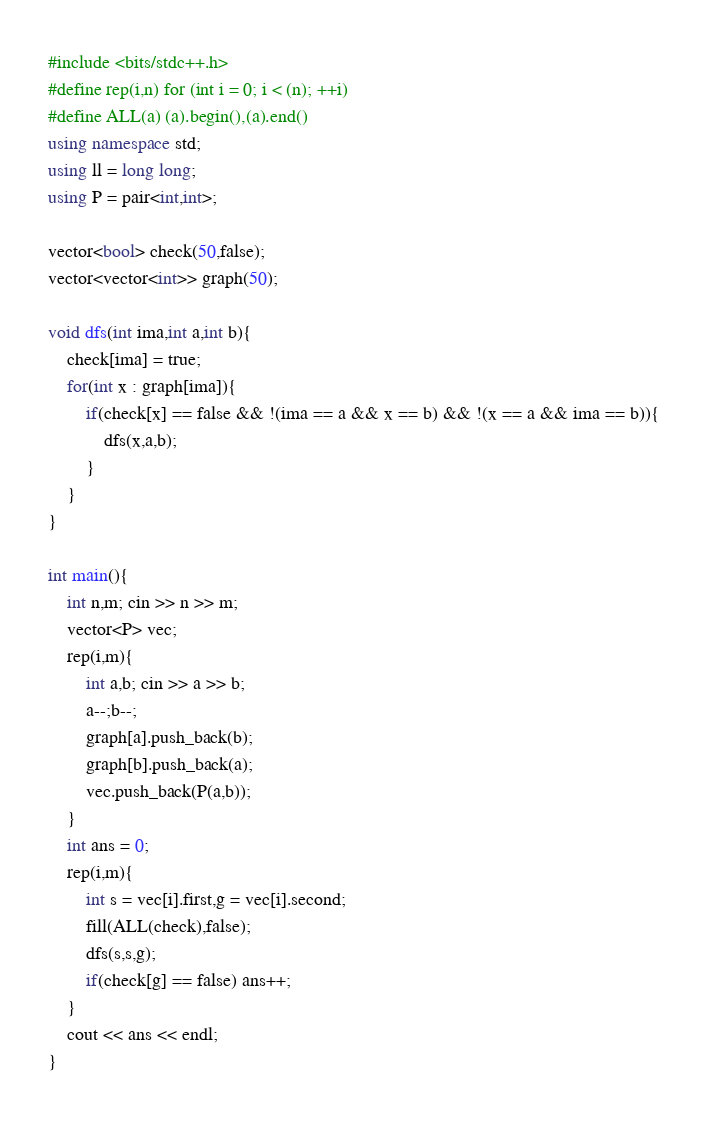Convert code to text. <code><loc_0><loc_0><loc_500><loc_500><_C++_>#include <bits/stdc++.h>
#define rep(i,n) for (int i = 0; i < (n); ++i)
#define ALL(a) (a).begin(),(a).end()
using namespace std;
using ll = long long;
using P = pair<int,int>;

vector<bool> check(50,false);
vector<vector<int>> graph(50);

void dfs(int ima,int a,int b){
    check[ima] = true;
    for(int x : graph[ima]){
        if(check[x] == false && !(ima == a && x == b) && !(x == a && ima == b)){
            dfs(x,a,b);
        }
    }
}

int main(){
    int n,m; cin >> n >> m;
    vector<P> vec;
    rep(i,m){
        int a,b; cin >> a >> b;
        a--;b--;
        graph[a].push_back(b);
        graph[b].push_back(a);
        vec.push_back(P(a,b));
    }
    int ans = 0;
    rep(i,m){
        int s = vec[i].first,g = vec[i].second;
        fill(ALL(check),false);
        dfs(s,s,g);
        if(check[g] == false) ans++;
    }
    cout << ans << endl;
}</code> 